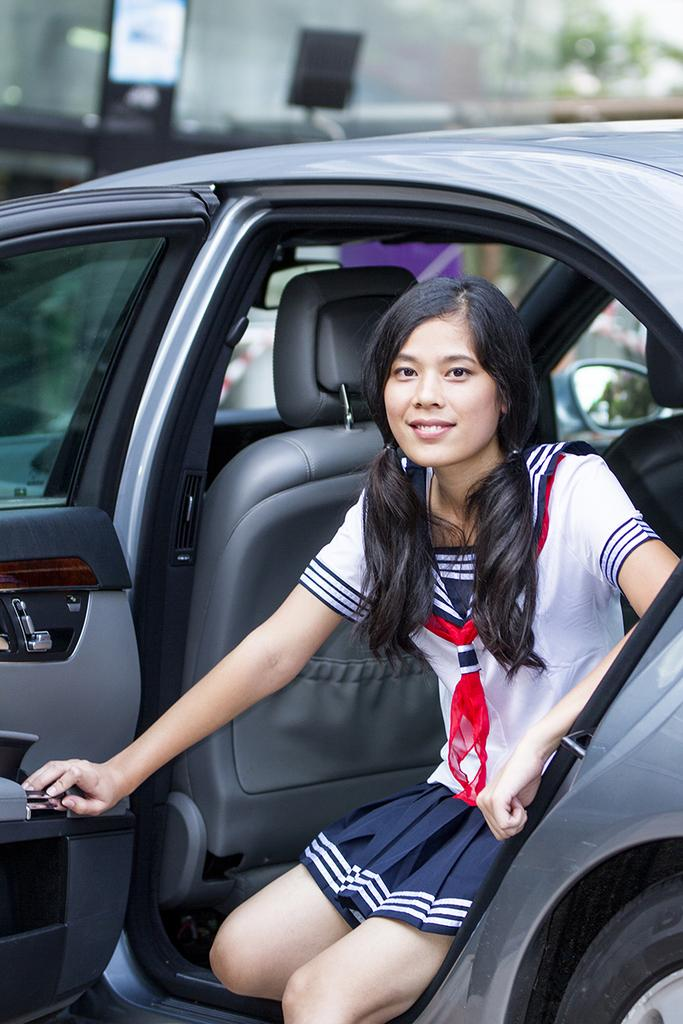Who or what is present in the image? There is a person in the image. What is the person doing in the image? The person is sitting inside a car. What type of dust can be seen on the goose in the image? There is no goose or dust present in the image; it only features a person sitting inside a car. 